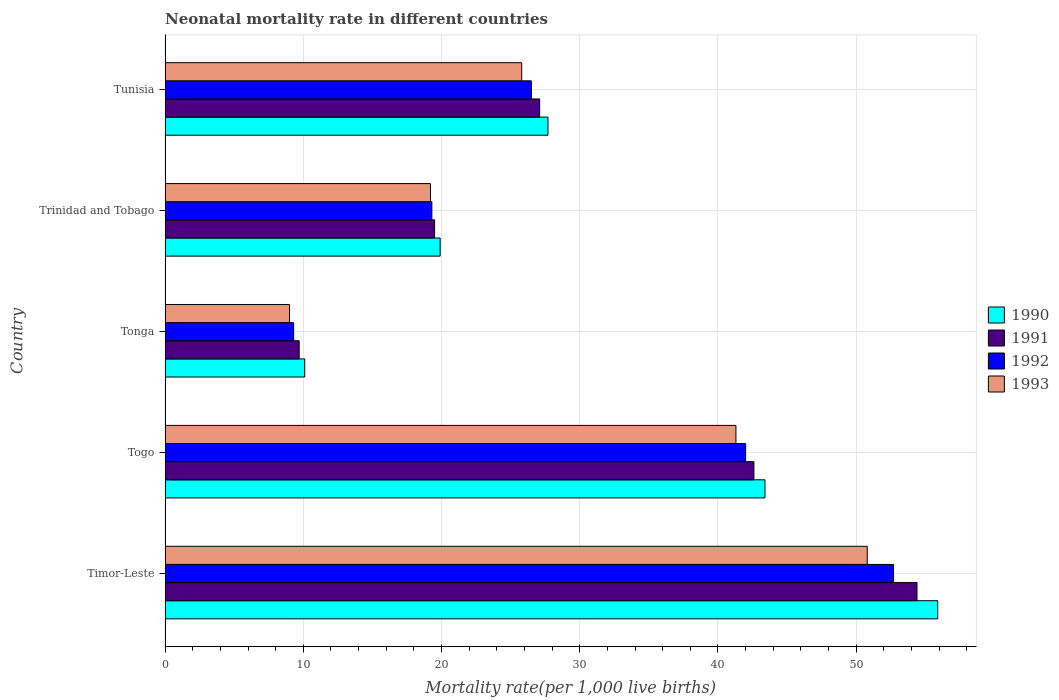How many groups of bars are there?
Give a very brief answer. 5. Are the number of bars on each tick of the Y-axis equal?
Your answer should be very brief. Yes. What is the label of the 3rd group of bars from the top?
Your answer should be compact. Tonga. In how many cases, is the number of bars for a given country not equal to the number of legend labels?
Provide a succinct answer. 0. What is the neonatal mortality rate in 1990 in Tunisia?
Make the answer very short. 27.7. Across all countries, what is the maximum neonatal mortality rate in 1993?
Provide a succinct answer. 50.8. Across all countries, what is the minimum neonatal mortality rate in 1990?
Your response must be concise. 10.1. In which country was the neonatal mortality rate in 1991 maximum?
Offer a terse response. Timor-Leste. In which country was the neonatal mortality rate in 1992 minimum?
Make the answer very short. Tonga. What is the total neonatal mortality rate in 1990 in the graph?
Keep it short and to the point. 157. What is the difference between the neonatal mortality rate in 1991 in Togo and the neonatal mortality rate in 1990 in Trinidad and Tobago?
Make the answer very short. 22.7. What is the average neonatal mortality rate in 1992 per country?
Provide a short and direct response. 29.96. What is the difference between the neonatal mortality rate in 1993 and neonatal mortality rate in 1991 in Tunisia?
Give a very brief answer. -1.3. What is the ratio of the neonatal mortality rate in 1991 in Togo to that in Trinidad and Tobago?
Offer a terse response. 2.18. Is the difference between the neonatal mortality rate in 1993 in Togo and Tunisia greater than the difference between the neonatal mortality rate in 1991 in Togo and Tunisia?
Your response must be concise. No. What is the difference between the highest and the lowest neonatal mortality rate in 1992?
Offer a very short reply. 43.4. Is the sum of the neonatal mortality rate in 1992 in Togo and Trinidad and Tobago greater than the maximum neonatal mortality rate in 1990 across all countries?
Ensure brevity in your answer.  Yes. What does the 2nd bar from the top in Tunisia represents?
Provide a short and direct response. 1992. How many bars are there?
Your response must be concise. 20. Are all the bars in the graph horizontal?
Your answer should be very brief. Yes. How many countries are there in the graph?
Ensure brevity in your answer.  5. What is the difference between two consecutive major ticks on the X-axis?
Offer a very short reply. 10. Are the values on the major ticks of X-axis written in scientific E-notation?
Your answer should be compact. No. Does the graph contain any zero values?
Your response must be concise. No. Does the graph contain grids?
Provide a short and direct response. Yes. Where does the legend appear in the graph?
Ensure brevity in your answer.  Center right. What is the title of the graph?
Make the answer very short. Neonatal mortality rate in different countries. What is the label or title of the X-axis?
Offer a terse response. Mortality rate(per 1,0 live births). What is the label or title of the Y-axis?
Give a very brief answer. Country. What is the Mortality rate(per 1,000 live births) in 1990 in Timor-Leste?
Provide a succinct answer. 55.9. What is the Mortality rate(per 1,000 live births) of 1991 in Timor-Leste?
Your response must be concise. 54.4. What is the Mortality rate(per 1,000 live births) of 1992 in Timor-Leste?
Your answer should be very brief. 52.7. What is the Mortality rate(per 1,000 live births) in 1993 in Timor-Leste?
Offer a very short reply. 50.8. What is the Mortality rate(per 1,000 live births) in 1990 in Togo?
Make the answer very short. 43.4. What is the Mortality rate(per 1,000 live births) in 1991 in Togo?
Keep it short and to the point. 42.6. What is the Mortality rate(per 1,000 live births) of 1993 in Togo?
Give a very brief answer. 41.3. What is the Mortality rate(per 1,000 live births) of 1990 in Tonga?
Provide a short and direct response. 10.1. What is the Mortality rate(per 1,000 live births) in 1992 in Tonga?
Ensure brevity in your answer.  9.3. What is the Mortality rate(per 1,000 live births) of 1990 in Trinidad and Tobago?
Ensure brevity in your answer.  19.9. What is the Mortality rate(per 1,000 live births) in 1992 in Trinidad and Tobago?
Your answer should be very brief. 19.3. What is the Mortality rate(per 1,000 live births) of 1990 in Tunisia?
Your response must be concise. 27.7. What is the Mortality rate(per 1,000 live births) of 1991 in Tunisia?
Provide a short and direct response. 27.1. What is the Mortality rate(per 1,000 live births) in 1992 in Tunisia?
Your answer should be compact. 26.5. What is the Mortality rate(per 1,000 live births) of 1993 in Tunisia?
Provide a short and direct response. 25.8. Across all countries, what is the maximum Mortality rate(per 1,000 live births) in 1990?
Keep it short and to the point. 55.9. Across all countries, what is the maximum Mortality rate(per 1,000 live births) of 1991?
Make the answer very short. 54.4. Across all countries, what is the maximum Mortality rate(per 1,000 live births) of 1992?
Give a very brief answer. 52.7. Across all countries, what is the maximum Mortality rate(per 1,000 live births) of 1993?
Ensure brevity in your answer.  50.8. Across all countries, what is the minimum Mortality rate(per 1,000 live births) in 1990?
Your answer should be very brief. 10.1. Across all countries, what is the minimum Mortality rate(per 1,000 live births) in 1993?
Provide a succinct answer. 9. What is the total Mortality rate(per 1,000 live births) in 1990 in the graph?
Provide a short and direct response. 157. What is the total Mortality rate(per 1,000 live births) of 1991 in the graph?
Your answer should be very brief. 153.3. What is the total Mortality rate(per 1,000 live births) of 1992 in the graph?
Provide a succinct answer. 149.8. What is the total Mortality rate(per 1,000 live births) of 1993 in the graph?
Give a very brief answer. 146.1. What is the difference between the Mortality rate(per 1,000 live births) in 1991 in Timor-Leste and that in Togo?
Your answer should be very brief. 11.8. What is the difference between the Mortality rate(per 1,000 live births) of 1993 in Timor-Leste and that in Togo?
Offer a very short reply. 9.5. What is the difference between the Mortality rate(per 1,000 live births) in 1990 in Timor-Leste and that in Tonga?
Offer a very short reply. 45.8. What is the difference between the Mortality rate(per 1,000 live births) in 1991 in Timor-Leste and that in Tonga?
Offer a terse response. 44.7. What is the difference between the Mortality rate(per 1,000 live births) of 1992 in Timor-Leste and that in Tonga?
Your response must be concise. 43.4. What is the difference between the Mortality rate(per 1,000 live births) of 1993 in Timor-Leste and that in Tonga?
Ensure brevity in your answer.  41.8. What is the difference between the Mortality rate(per 1,000 live births) of 1991 in Timor-Leste and that in Trinidad and Tobago?
Give a very brief answer. 34.9. What is the difference between the Mortality rate(per 1,000 live births) in 1992 in Timor-Leste and that in Trinidad and Tobago?
Provide a succinct answer. 33.4. What is the difference between the Mortality rate(per 1,000 live births) of 1993 in Timor-Leste and that in Trinidad and Tobago?
Your answer should be compact. 31.6. What is the difference between the Mortality rate(per 1,000 live births) of 1990 in Timor-Leste and that in Tunisia?
Ensure brevity in your answer.  28.2. What is the difference between the Mortality rate(per 1,000 live births) in 1991 in Timor-Leste and that in Tunisia?
Provide a short and direct response. 27.3. What is the difference between the Mortality rate(per 1,000 live births) in 1992 in Timor-Leste and that in Tunisia?
Give a very brief answer. 26.2. What is the difference between the Mortality rate(per 1,000 live births) of 1990 in Togo and that in Tonga?
Offer a terse response. 33.3. What is the difference between the Mortality rate(per 1,000 live births) of 1991 in Togo and that in Tonga?
Your response must be concise. 32.9. What is the difference between the Mortality rate(per 1,000 live births) in 1992 in Togo and that in Tonga?
Make the answer very short. 32.7. What is the difference between the Mortality rate(per 1,000 live births) of 1993 in Togo and that in Tonga?
Give a very brief answer. 32.3. What is the difference between the Mortality rate(per 1,000 live births) of 1990 in Togo and that in Trinidad and Tobago?
Provide a short and direct response. 23.5. What is the difference between the Mortality rate(per 1,000 live births) in 1991 in Togo and that in Trinidad and Tobago?
Offer a very short reply. 23.1. What is the difference between the Mortality rate(per 1,000 live births) in 1992 in Togo and that in Trinidad and Tobago?
Your response must be concise. 22.7. What is the difference between the Mortality rate(per 1,000 live births) in 1993 in Togo and that in Trinidad and Tobago?
Your answer should be compact. 22.1. What is the difference between the Mortality rate(per 1,000 live births) of 1990 in Togo and that in Tunisia?
Your answer should be very brief. 15.7. What is the difference between the Mortality rate(per 1,000 live births) of 1991 in Togo and that in Tunisia?
Keep it short and to the point. 15.5. What is the difference between the Mortality rate(per 1,000 live births) of 1993 in Togo and that in Tunisia?
Give a very brief answer. 15.5. What is the difference between the Mortality rate(per 1,000 live births) in 1991 in Tonga and that in Trinidad and Tobago?
Provide a succinct answer. -9.8. What is the difference between the Mortality rate(per 1,000 live births) of 1993 in Tonga and that in Trinidad and Tobago?
Offer a very short reply. -10.2. What is the difference between the Mortality rate(per 1,000 live births) in 1990 in Tonga and that in Tunisia?
Your response must be concise. -17.6. What is the difference between the Mortality rate(per 1,000 live births) in 1991 in Tonga and that in Tunisia?
Your answer should be compact. -17.4. What is the difference between the Mortality rate(per 1,000 live births) of 1992 in Tonga and that in Tunisia?
Provide a succinct answer. -17.2. What is the difference between the Mortality rate(per 1,000 live births) of 1993 in Tonga and that in Tunisia?
Keep it short and to the point. -16.8. What is the difference between the Mortality rate(per 1,000 live births) in 1990 in Timor-Leste and the Mortality rate(per 1,000 live births) in 1991 in Togo?
Offer a very short reply. 13.3. What is the difference between the Mortality rate(per 1,000 live births) of 1991 in Timor-Leste and the Mortality rate(per 1,000 live births) of 1992 in Togo?
Provide a short and direct response. 12.4. What is the difference between the Mortality rate(per 1,000 live births) in 1992 in Timor-Leste and the Mortality rate(per 1,000 live births) in 1993 in Togo?
Your answer should be very brief. 11.4. What is the difference between the Mortality rate(per 1,000 live births) of 1990 in Timor-Leste and the Mortality rate(per 1,000 live births) of 1991 in Tonga?
Make the answer very short. 46.2. What is the difference between the Mortality rate(per 1,000 live births) in 1990 in Timor-Leste and the Mortality rate(per 1,000 live births) in 1992 in Tonga?
Your response must be concise. 46.6. What is the difference between the Mortality rate(per 1,000 live births) in 1990 in Timor-Leste and the Mortality rate(per 1,000 live births) in 1993 in Tonga?
Ensure brevity in your answer.  46.9. What is the difference between the Mortality rate(per 1,000 live births) of 1991 in Timor-Leste and the Mortality rate(per 1,000 live births) of 1992 in Tonga?
Provide a short and direct response. 45.1. What is the difference between the Mortality rate(per 1,000 live births) in 1991 in Timor-Leste and the Mortality rate(per 1,000 live births) in 1993 in Tonga?
Ensure brevity in your answer.  45.4. What is the difference between the Mortality rate(per 1,000 live births) in 1992 in Timor-Leste and the Mortality rate(per 1,000 live births) in 1993 in Tonga?
Your response must be concise. 43.7. What is the difference between the Mortality rate(per 1,000 live births) of 1990 in Timor-Leste and the Mortality rate(per 1,000 live births) of 1991 in Trinidad and Tobago?
Keep it short and to the point. 36.4. What is the difference between the Mortality rate(per 1,000 live births) in 1990 in Timor-Leste and the Mortality rate(per 1,000 live births) in 1992 in Trinidad and Tobago?
Provide a short and direct response. 36.6. What is the difference between the Mortality rate(per 1,000 live births) in 1990 in Timor-Leste and the Mortality rate(per 1,000 live births) in 1993 in Trinidad and Tobago?
Provide a short and direct response. 36.7. What is the difference between the Mortality rate(per 1,000 live births) in 1991 in Timor-Leste and the Mortality rate(per 1,000 live births) in 1992 in Trinidad and Tobago?
Offer a very short reply. 35.1. What is the difference between the Mortality rate(per 1,000 live births) of 1991 in Timor-Leste and the Mortality rate(per 1,000 live births) of 1993 in Trinidad and Tobago?
Offer a terse response. 35.2. What is the difference between the Mortality rate(per 1,000 live births) in 1992 in Timor-Leste and the Mortality rate(per 1,000 live births) in 1993 in Trinidad and Tobago?
Ensure brevity in your answer.  33.5. What is the difference between the Mortality rate(per 1,000 live births) in 1990 in Timor-Leste and the Mortality rate(per 1,000 live births) in 1991 in Tunisia?
Keep it short and to the point. 28.8. What is the difference between the Mortality rate(per 1,000 live births) of 1990 in Timor-Leste and the Mortality rate(per 1,000 live births) of 1992 in Tunisia?
Provide a short and direct response. 29.4. What is the difference between the Mortality rate(per 1,000 live births) in 1990 in Timor-Leste and the Mortality rate(per 1,000 live births) in 1993 in Tunisia?
Ensure brevity in your answer.  30.1. What is the difference between the Mortality rate(per 1,000 live births) in 1991 in Timor-Leste and the Mortality rate(per 1,000 live births) in 1992 in Tunisia?
Ensure brevity in your answer.  27.9. What is the difference between the Mortality rate(per 1,000 live births) in 1991 in Timor-Leste and the Mortality rate(per 1,000 live births) in 1993 in Tunisia?
Offer a terse response. 28.6. What is the difference between the Mortality rate(per 1,000 live births) in 1992 in Timor-Leste and the Mortality rate(per 1,000 live births) in 1993 in Tunisia?
Provide a short and direct response. 26.9. What is the difference between the Mortality rate(per 1,000 live births) of 1990 in Togo and the Mortality rate(per 1,000 live births) of 1991 in Tonga?
Your answer should be very brief. 33.7. What is the difference between the Mortality rate(per 1,000 live births) in 1990 in Togo and the Mortality rate(per 1,000 live births) in 1992 in Tonga?
Give a very brief answer. 34.1. What is the difference between the Mortality rate(per 1,000 live births) in 1990 in Togo and the Mortality rate(per 1,000 live births) in 1993 in Tonga?
Offer a terse response. 34.4. What is the difference between the Mortality rate(per 1,000 live births) in 1991 in Togo and the Mortality rate(per 1,000 live births) in 1992 in Tonga?
Your response must be concise. 33.3. What is the difference between the Mortality rate(per 1,000 live births) in 1991 in Togo and the Mortality rate(per 1,000 live births) in 1993 in Tonga?
Ensure brevity in your answer.  33.6. What is the difference between the Mortality rate(per 1,000 live births) in 1992 in Togo and the Mortality rate(per 1,000 live births) in 1993 in Tonga?
Make the answer very short. 33. What is the difference between the Mortality rate(per 1,000 live births) in 1990 in Togo and the Mortality rate(per 1,000 live births) in 1991 in Trinidad and Tobago?
Your answer should be very brief. 23.9. What is the difference between the Mortality rate(per 1,000 live births) of 1990 in Togo and the Mortality rate(per 1,000 live births) of 1992 in Trinidad and Tobago?
Make the answer very short. 24.1. What is the difference between the Mortality rate(per 1,000 live births) in 1990 in Togo and the Mortality rate(per 1,000 live births) in 1993 in Trinidad and Tobago?
Keep it short and to the point. 24.2. What is the difference between the Mortality rate(per 1,000 live births) in 1991 in Togo and the Mortality rate(per 1,000 live births) in 1992 in Trinidad and Tobago?
Keep it short and to the point. 23.3. What is the difference between the Mortality rate(per 1,000 live births) in 1991 in Togo and the Mortality rate(per 1,000 live births) in 1993 in Trinidad and Tobago?
Your answer should be very brief. 23.4. What is the difference between the Mortality rate(per 1,000 live births) in 1992 in Togo and the Mortality rate(per 1,000 live births) in 1993 in Trinidad and Tobago?
Make the answer very short. 22.8. What is the difference between the Mortality rate(per 1,000 live births) of 1990 in Togo and the Mortality rate(per 1,000 live births) of 1992 in Tunisia?
Offer a terse response. 16.9. What is the difference between the Mortality rate(per 1,000 live births) in 1990 in Togo and the Mortality rate(per 1,000 live births) in 1993 in Tunisia?
Offer a terse response. 17.6. What is the difference between the Mortality rate(per 1,000 live births) in 1990 in Tonga and the Mortality rate(per 1,000 live births) in 1991 in Trinidad and Tobago?
Your response must be concise. -9.4. What is the difference between the Mortality rate(per 1,000 live births) of 1990 in Tonga and the Mortality rate(per 1,000 live births) of 1992 in Trinidad and Tobago?
Provide a succinct answer. -9.2. What is the difference between the Mortality rate(per 1,000 live births) in 1990 in Tonga and the Mortality rate(per 1,000 live births) in 1991 in Tunisia?
Provide a short and direct response. -17. What is the difference between the Mortality rate(per 1,000 live births) of 1990 in Tonga and the Mortality rate(per 1,000 live births) of 1992 in Tunisia?
Provide a short and direct response. -16.4. What is the difference between the Mortality rate(per 1,000 live births) of 1990 in Tonga and the Mortality rate(per 1,000 live births) of 1993 in Tunisia?
Your answer should be very brief. -15.7. What is the difference between the Mortality rate(per 1,000 live births) of 1991 in Tonga and the Mortality rate(per 1,000 live births) of 1992 in Tunisia?
Keep it short and to the point. -16.8. What is the difference between the Mortality rate(per 1,000 live births) in 1991 in Tonga and the Mortality rate(per 1,000 live births) in 1993 in Tunisia?
Your answer should be very brief. -16.1. What is the difference between the Mortality rate(per 1,000 live births) in 1992 in Tonga and the Mortality rate(per 1,000 live births) in 1993 in Tunisia?
Ensure brevity in your answer.  -16.5. What is the difference between the Mortality rate(per 1,000 live births) of 1990 in Trinidad and Tobago and the Mortality rate(per 1,000 live births) of 1993 in Tunisia?
Keep it short and to the point. -5.9. What is the difference between the Mortality rate(per 1,000 live births) of 1991 in Trinidad and Tobago and the Mortality rate(per 1,000 live births) of 1993 in Tunisia?
Make the answer very short. -6.3. What is the average Mortality rate(per 1,000 live births) in 1990 per country?
Offer a terse response. 31.4. What is the average Mortality rate(per 1,000 live births) of 1991 per country?
Offer a terse response. 30.66. What is the average Mortality rate(per 1,000 live births) of 1992 per country?
Your answer should be very brief. 29.96. What is the average Mortality rate(per 1,000 live births) of 1993 per country?
Provide a succinct answer. 29.22. What is the difference between the Mortality rate(per 1,000 live births) in 1990 and Mortality rate(per 1,000 live births) in 1991 in Timor-Leste?
Your response must be concise. 1.5. What is the difference between the Mortality rate(per 1,000 live births) of 1990 and Mortality rate(per 1,000 live births) of 1993 in Timor-Leste?
Offer a terse response. 5.1. What is the difference between the Mortality rate(per 1,000 live births) of 1992 and Mortality rate(per 1,000 live births) of 1993 in Timor-Leste?
Your answer should be very brief. 1.9. What is the difference between the Mortality rate(per 1,000 live births) of 1990 and Mortality rate(per 1,000 live births) of 1992 in Togo?
Make the answer very short. 1.4. What is the difference between the Mortality rate(per 1,000 live births) in 1990 and Mortality rate(per 1,000 live births) in 1993 in Togo?
Keep it short and to the point. 2.1. What is the difference between the Mortality rate(per 1,000 live births) in 1991 and Mortality rate(per 1,000 live births) in 1992 in Togo?
Your answer should be compact. 0.6. What is the difference between the Mortality rate(per 1,000 live births) of 1991 and Mortality rate(per 1,000 live births) of 1993 in Togo?
Provide a succinct answer. 1.3. What is the difference between the Mortality rate(per 1,000 live births) in 1990 and Mortality rate(per 1,000 live births) in 1991 in Tonga?
Provide a succinct answer. 0.4. What is the difference between the Mortality rate(per 1,000 live births) in 1991 and Mortality rate(per 1,000 live births) in 1993 in Tonga?
Ensure brevity in your answer.  0.7. What is the difference between the Mortality rate(per 1,000 live births) in 1992 and Mortality rate(per 1,000 live births) in 1993 in Tonga?
Offer a terse response. 0.3. What is the difference between the Mortality rate(per 1,000 live births) in 1990 and Mortality rate(per 1,000 live births) in 1991 in Trinidad and Tobago?
Your response must be concise. 0.4. What is the difference between the Mortality rate(per 1,000 live births) in 1990 and Mortality rate(per 1,000 live births) in 1993 in Trinidad and Tobago?
Give a very brief answer. 0.7. What is the difference between the Mortality rate(per 1,000 live births) of 1990 and Mortality rate(per 1,000 live births) of 1993 in Tunisia?
Make the answer very short. 1.9. What is the difference between the Mortality rate(per 1,000 live births) of 1991 and Mortality rate(per 1,000 live births) of 1992 in Tunisia?
Provide a succinct answer. 0.6. What is the difference between the Mortality rate(per 1,000 live births) of 1992 and Mortality rate(per 1,000 live births) of 1993 in Tunisia?
Offer a terse response. 0.7. What is the ratio of the Mortality rate(per 1,000 live births) of 1990 in Timor-Leste to that in Togo?
Provide a succinct answer. 1.29. What is the ratio of the Mortality rate(per 1,000 live births) in 1991 in Timor-Leste to that in Togo?
Make the answer very short. 1.28. What is the ratio of the Mortality rate(per 1,000 live births) in 1992 in Timor-Leste to that in Togo?
Provide a succinct answer. 1.25. What is the ratio of the Mortality rate(per 1,000 live births) in 1993 in Timor-Leste to that in Togo?
Give a very brief answer. 1.23. What is the ratio of the Mortality rate(per 1,000 live births) of 1990 in Timor-Leste to that in Tonga?
Provide a short and direct response. 5.53. What is the ratio of the Mortality rate(per 1,000 live births) in 1991 in Timor-Leste to that in Tonga?
Provide a short and direct response. 5.61. What is the ratio of the Mortality rate(per 1,000 live births) of 1992 in Timor-Leste to that in Tonga?
Your answer should be very brief. 5.67. What is the ratio of the Mortality rate(per 1,000 live births) of 1993 in Timor-Leste to that in Tonga?
Make the answer very short. 5.64. What is the ratio of the Mortality rate(per 1,000 live births) in 1990 in Timor-Leste to that in Trinidad and Tobago?
Provide a short and direct response. 2.81. What is the ratio of the Mortality rate(per 1,000 live births) in 1991 in Timor-Leste to that in Trinidad and Tobago?
Offer a terse response. 2.79. What is the ratio of the Mortality rate(per 1,000 live births) in 1992 in Timor-Leste to that in Trinidad and Tobago?
Give a very brief answer. 2.73. What is the ratio of the Mortality rate(per 1,000 live births) of 1993 in Timor-Leste to that in Trinidad and Tobago?
Your answer should be compact. 2.65. What is the ratio of the Mortality rate(per 1,000 live births) of 1990 in Timor-Leste to that in Tunisia?
Make the answer very short. 2.02. What is the ratio of the Mortality rate(per 1,000 live births) in 1991 in Timor-Leste to that in Tunisia?
Offer a terse response. 2.01. What is the ratio of the Mortality rate(per 1,000 live births) of 1992 in Timor-Leste to that in Tunisia?
Offer a very short reply. 1.99. What is the ratio of the Mortality rate(per 1,000 live births) in 1993 in Timor-Leste to that in Tunisia?
Ensure brevity in your answer.  1.97. What is the ratio of the Mortality rate(per 1,000 live births) in 1990 in Togo to that in Tonga?
Give a very brief answer. 4.3. What is the ratio of the Mortality rate(per 1,000 live births) in 1991 in Togo to that in Tonga?
Make the answer very short. 4.39. What is the ratio of the Mortality rate(per 1,000 live births) of 1992 in Togo to that in Tonga?
Offer a terse response. 4.52. What is the ratio of the Mortality rate(per 1,000 live births) of 1993 in Togo to that in Tonga?
Give a very brief answer. 4.59. What is the ratio of the Mortality rate(per 1,000 live births) of 1990 in Togo to that in Trinidad and Tobago?
Provide a short and direct response. 2.18. What is the ratio of the Mortality rate(per 1,000 live births) of 1991 in Togo to that in Trinidad and Tobago?
Your answer should be compact. 2.18. What is the ratio of the Mortality rate(per 1,000 live births) of 1992 in Togo to that in Trinidad and Tobago?
Your answer should be very brief. 2.18. What is the ratio of the Mortality rate(per 1,000 live births) in 1993 in Togo to that in Trinidad and Tobago?
Offer a terse response. 2.15. What is the ratio of the Mortality rate(per 1,000 live births) of 1990 in Togo to that in Tunisia?
Your answer should be very brief. 1.57. What is the ratio of the Mortality rate(per 1,000 live births) of 1991 in Togo to that in Tunisia?
Offer a terse response. 1.57. What is the ratio of the Mortality rate(per 1,000 live births) of 1992 in Togo to that in Tunisia?
Your answer should be compact. 1.58. What is the ratio of the Mortality rate(per 1,000 live births) in 1993 in Togo to that in Tunisia?
Provide a succinct answer. 1.6. What is the ratio of the Mortality rate(per 1,000 live births) in 1990 in Tonga to that in Trinidad and Tobago?
Offer a terse response. 0.51. What is the ratio of the Mortality rate(per 1,000 live births) in 1991 in Tonga to that in Trinidad and Tobago?
Your answer should be very brief. 0.5. What is the ratio of the Mortality rate(per 1,000 live births) of 1992 in Tonga to that in Trinidad and Tobago?
Keep it short and to the point. 0.48. What is the ratio of the Mortality rate(per 1,000 live births) of 1993 in Tonga to that in Trinidad and Tobago?
Offer a terse response. 0.47. What is the ratio of the Mortality rate(per 1,000 live births) in 1990 in Tonga to that in Tunisia?
Offer a terse response. 0.36. What is the ratio of the Mortality rate(per 1,000 live births) of 1991 in Tonga to that in Tunisia?
Keep it short and to the point. 0.36. What is the ratio of the Mortality rate(per 1,000 live births) of 1992 in Tonga to that in Tunisia?
Ensure brevity in your answer.  0.35. What is the ratio of the Mortality rate(per 1,000 live births) of 1993 in Tonga to that in Tunisia?
Your answer should be compact. 0.35. What is the ratio of the Mortality rate(per 1,000 live births) of 1990 in Trinidad and Tobago to that in Tunisia?
Keep it short and to the point. 0.72. What is the ratio of the Mortality rate(per 1,000 live births) of 1991 in Trinidad and Tobago to that in Tunisia?
Make the answer very short. 0.72. What is the ratio of the Mortality rate(per 1,000 live births) in 1992 in Trinidad and Tobago to that in Tunisia?
Provide a short and direct response. 0.73. What is the ratio of the Mortality rate(per 1,000 live births) of 1993 in Trinidad and Tobago to that in Tunisia?
Ensure brevity in your answer.  0.74. What is the difference between the highest and the second highest Mortality rate(per 1,000 live births) of 1990?
Make the answer very short. 12.5. What is the difference between the highest and the second highest Mortality rate(per 1,000 live births) in 1991?
Make the answer very short. 11.8. What is the difference between the highest and the second highest Mortality rate(per 1,000 live births) in 1992?
Keep it short and to the point. 10.7. What is the difference between the highest and the second highest Mortality rate(per 1,000 live births) of 1993?
Provide a succinct answer. 9.5. What is the difference between the highest and the lowest Mortality rate(per 1,000 live births) in 1990?
Ensure brevity in your answer.  45.8. What is the difference between the highest and the lowest Mortality rate(per 1,000 live births) in 1991?
Provide a short and direct response. 44.7. What is the difference between the highest and the lowest Mortality rate(per 1,000 live births) in 1992?
Provide a short and direct response. 43.4. What is the difference between the highest and the lowest Mortality rate(per 1,000 live births) of 1993?
Keep it short and to the point. 41.8. 